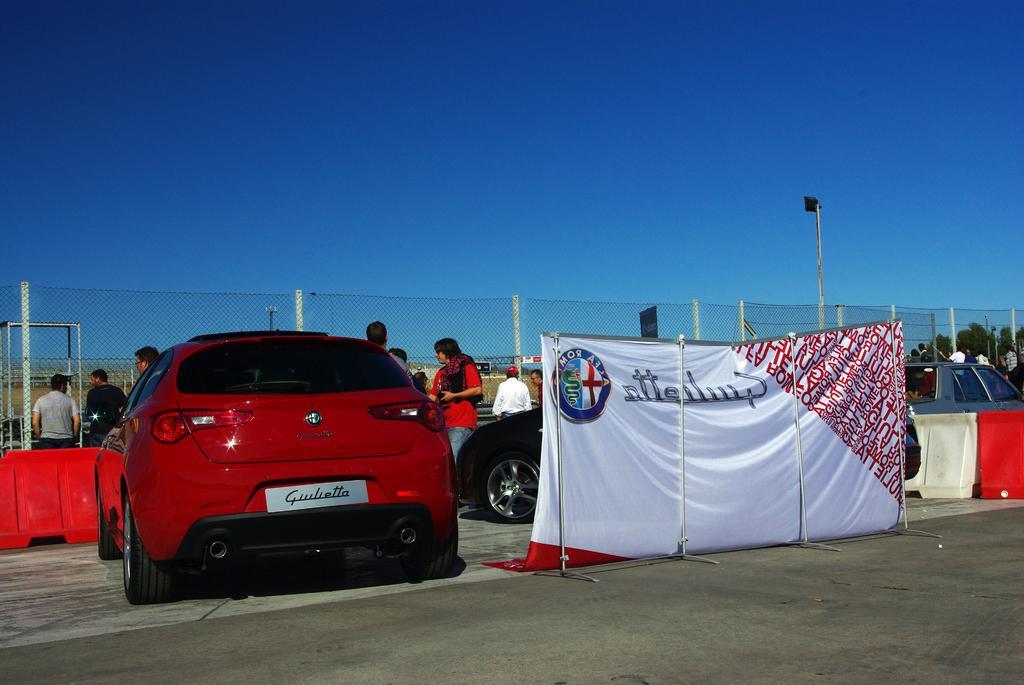In one or two sentences, can you explain what this image depicts? In this image we can see cars and persons. In the foreground we can see a clot attached to the stand. On the cloth there is some text. Behind the persons we can see the fencing. On the right side, we can see the barriers. At the top we can see the sky. 